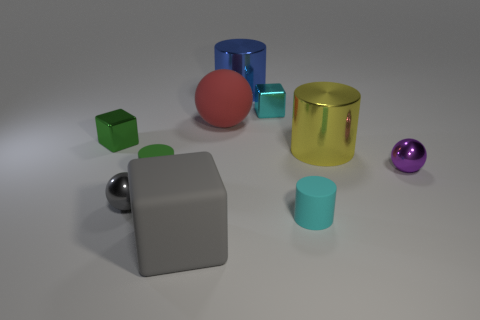What number of things are either small purple objects or metal cylinders to the left of the small cyan metallic object?
Make the answer very short. 2. What number of other objects are there of the same material as the yellow thing?
Offer a very short reply. 5. How many objects are shiny things or shiny cubes?
Keep it short and to the point. 6. Are there more tiny green cylinders that are in front of the tiny gray metallic thing than tiny gray balls that are behind the small green matte thing?
Your response must be concise. No. Is the color of the large cylinder in front of the blue shiny object the same as the small object that is behind the small green shiny thing?
Provide a short and direct response. No. What size is the metal cube right of the shiny cube that is left of the big cylinder on the left side of the cyan rubber object?
Offer a very short reply. Small. What color is the other large thing that is the same shape as the yellow metallic thing?
Make the answer very short. Blue. Is the number of rubber spheres right of the big blue object greater than the number of green objects?
Make the answer very short. No. There is a cyan rubber object; is it the same shape as the tiny object that is to the left of the small gray metallic sphere?
Offer a very short reply. No. Is there any other thing that has the same size as the cyan metallic thing?
Offer a very short reply. Yes. 